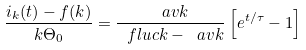Convert formula to latex. <formula><loc_0><loc_0><loc_500><loc_500>\frac { i _ { k } ( t ) - f ( k ) } { k \Theta _ { 0 } } = \frac { \ a v k } { \ f l u c k - \ a v k } \left [ e ^ { t / \tau } - 1 \right ]</formula> 